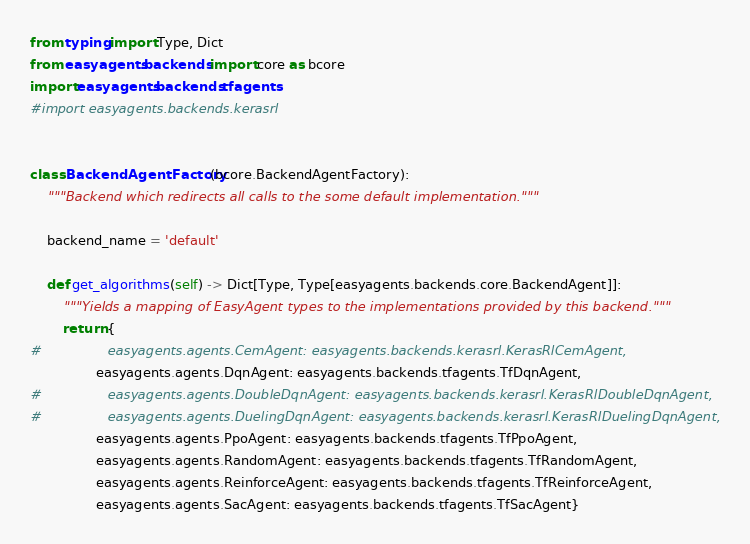<code> <loc_0><loc_0><loc_500><loc_500><_Python_>from typing import Type, Dict
from easyagents.backends import core as bcore
import easyagents.backends.tfagents
#import easyagents.backends.kerasrl


class BackendAgentFactory(bcore.BackendAgentFactory):
    """Backend which redirects all calls to the some default implementation."""

    backend_name = 'default'

    def get_algorithms(self) -> Dict[Type, Type[easyagents.backends.core.BackendAgent]]:
        """Yields a mapping of EasyAgent types to the implementations provided by this backend."""
        return {
#                easyagents.agents.CemAgent: easyagents.backends.kerasrl.KerasRlCemAgent,
                easyagents.agents.DqnAgent: easyagents.backends.tfagents.TfDqnAgent,
#                easyagents.agents.DoubleDqnAgent: easyagents.backends.kerasrl.KerasRlDoubleDqnAgent,
#                easyagents.agents.DuelingDqnAgent: easyagents.backends.kerasrl.KerasRlDuelingDqnAgent,
                easyagents.agents.PpoAgent: easyagents.backends.tfagents.TfPpoAgent,
                easyagents.agents.RandomAgent: easyagents.backends.tfagents.TfRandomAgent,
                easyagents.agents.ReinforceAgent: easyagents.backends.tfagents.TfReinforceAgent,
                easyagents.agents.SacAgent: easyagents.backends.tfagents.TfSacAgent}
</code> 